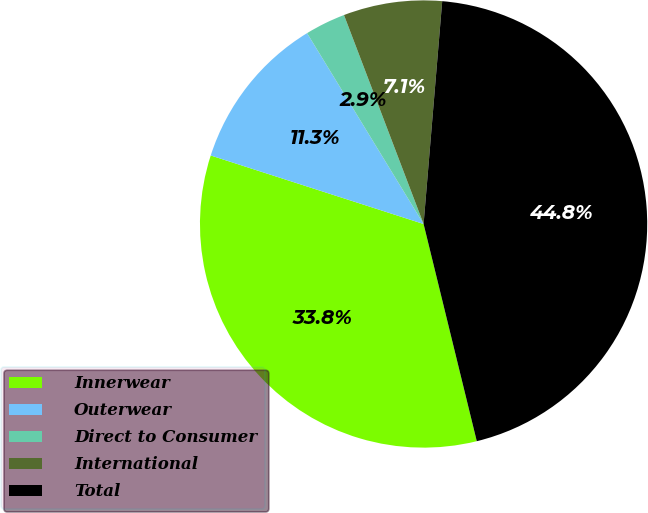<chart> <loc_0><loc_0><loc_500><loc_500><pie_chart><fcel>Innerwear<fcel>Outerwear<fcel>Direct to Consumer<fcel>International<fcel>Total<nl><fcel>33.78%<fcel>11.32%<fcel>2.93%<fcel>7.12%<fcel>44.85%<nl></chart> 